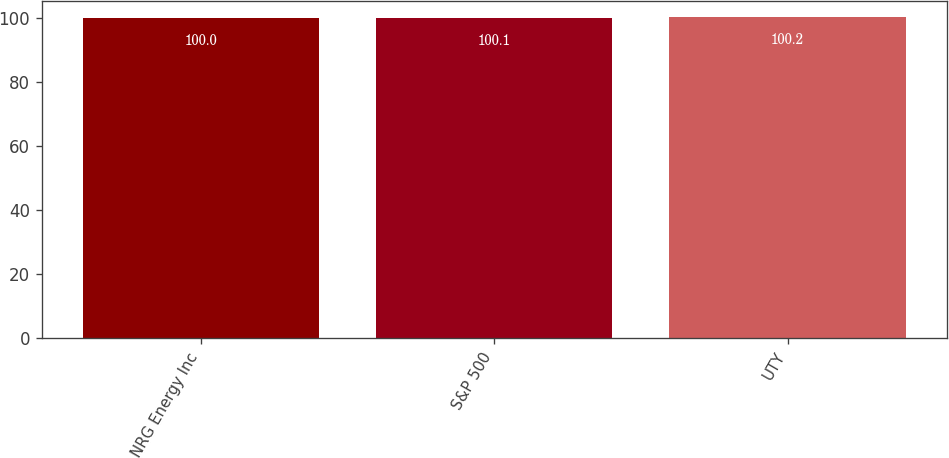Convert chart to OTSL. <chart><loc_0><loc_0><loc_500><loc_500><bar_chart><fcel>NRG Energy Inc<fcel>S&P 500<fcel>UTY<nl><fcel>100<fcel>100.1<fcel>100.2<nl></chart> 